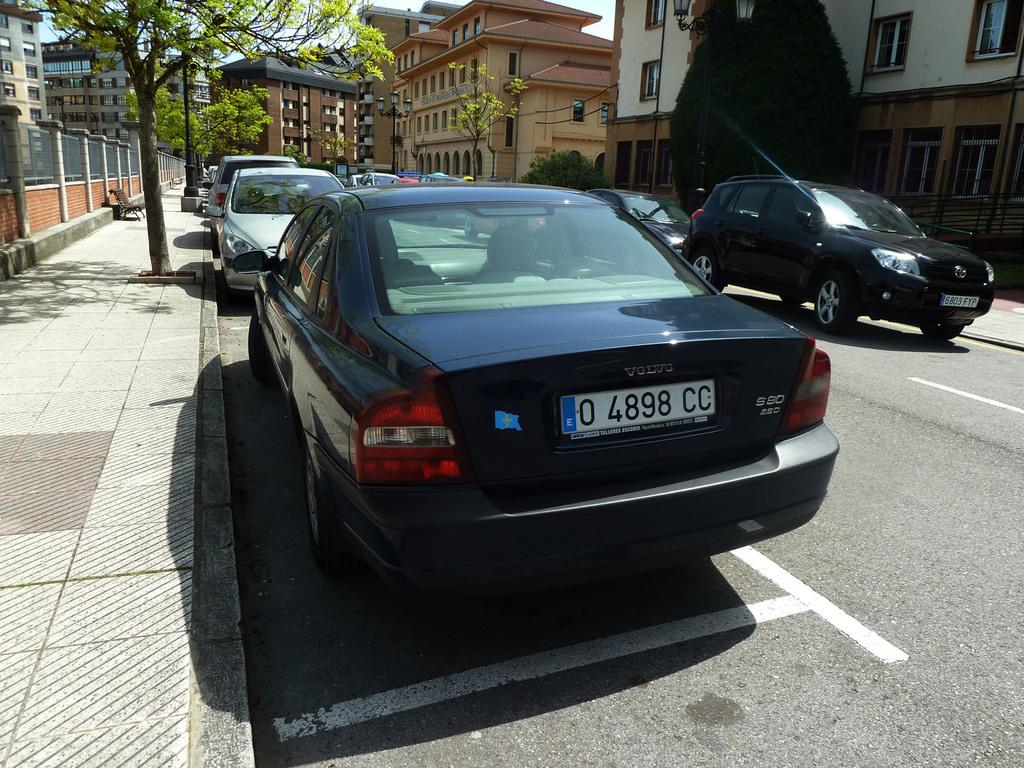Who made this car?
Your response must be concise. Volvo. What is the license plate number?
Provide a succinct answer. 0 4898 cc. 